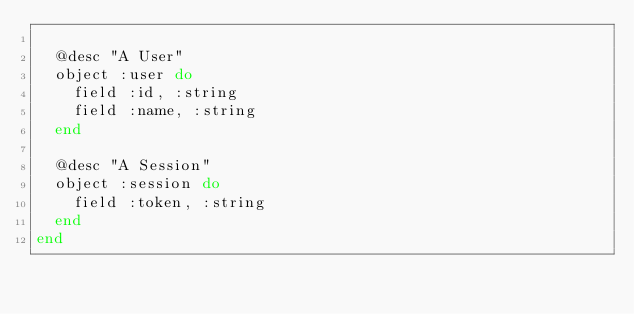<code> <loc_0><loc_0><loc_500><loc_500><_Elixir_>
  @desc "A User"
  object :user do
    field :id, :string
    field :name, :string
  end

  @desc "A Session"
  object :session do
    field :token, :string
  end
end
</code> 